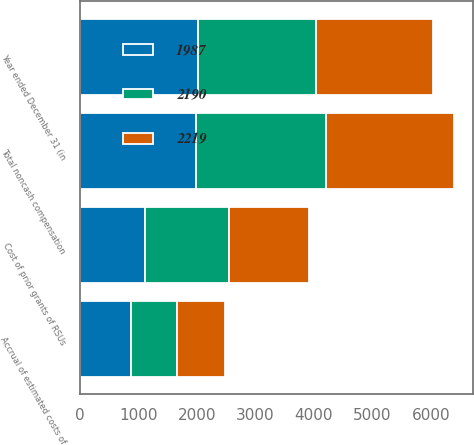Convert chart. <chart><loc_0><loc_0><loc_500><loc_500><stacked_bar_chart><ecel><fcel>Year ended December 31 (in<fcel>Cost of prior grants of RSUs<fcel>Accrual of estimated costs of<fcel>Total noncash compensation<nl><fcel>1987<fcel>2015<fcel>1109<fcel>878<fcel>1987<nl><fcel>2219<fcel>2014<fcel>1371<fcel>819<fcel>2190<nl><fcel>2190<fcel>2013<fcel>1440<fcel>779<fcel>2219<nl></chart> 